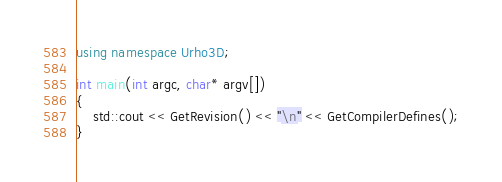<code> <loc_0><loc_0><loc_500><loc_500><_C++_>using namespace Urho3D;

int main(int argc, char* argv[])
{
    std::cout << GetRevision() << "\n" << GetCompilerDefines();
}
</code> 